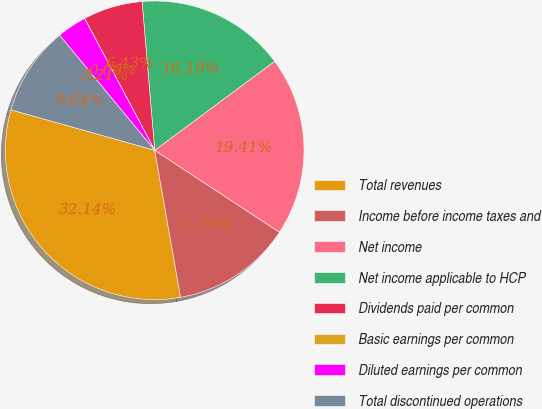Convert chart. <chart><loc_0><loc_0><loc_500><loc_500><pie_chart><fcel>Total revenues<fcel>Income before income taxes and<fcel>Net income<fcel>Net income applicable to HCP<fcel>Dividends paid per common<fcel>Basic earnings per common<fcel>Diluted earnings per common<fcel>Total discontinued operations<nl><fcel>32.14%<fcel>12.98%<fcel>19.41%<fcel>16.19%<fcel>6.43%<fcel>0.0%<fcel>3.21%<fcel>9.64%<nl></chart> 